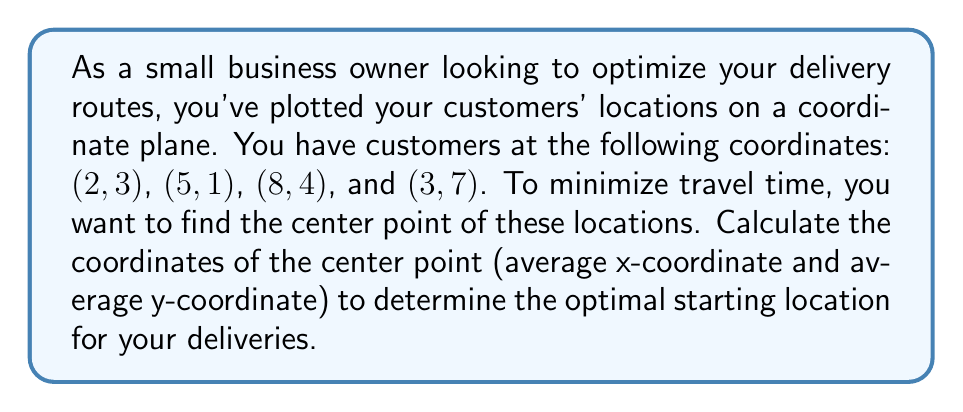Solve this math problem. To find the center point of multiple coordinates, we need to calculate the average of the x-coordinates and the average of the y-coordinates separately. This method is also known as finding the centroid.

1. List all x-coordinates: 2, 5, 8, 3
2. List all y-coordinates: 3, 1, 4, 7

3. Calculate the average x-coordinate:
   $$\bar{x} = \frac{x_1 + x_2 + x_3 + x_4}{4} = \frac{2 + 5 + 8 + 3}{4} = \frac{18}{4} = 4.5$$

4. Calculate the average y-coordinate:
   $$\bar{y} = \frac{y_1 + y_2 + y_3 + y_4}{4} = \frac{3 + 1 + 4 + 7}{4} = \frac{15}{4} = 3.75$$

5. The center point is $(\bar{x}, \bar{y}) = (4.5, 3.75)$

This point represents the optimal starting location for your deliveries, as it minimizes the overall distance to all customer locations.
Answer: The coordinates of the center point are $(4.5, 3.75)$. 